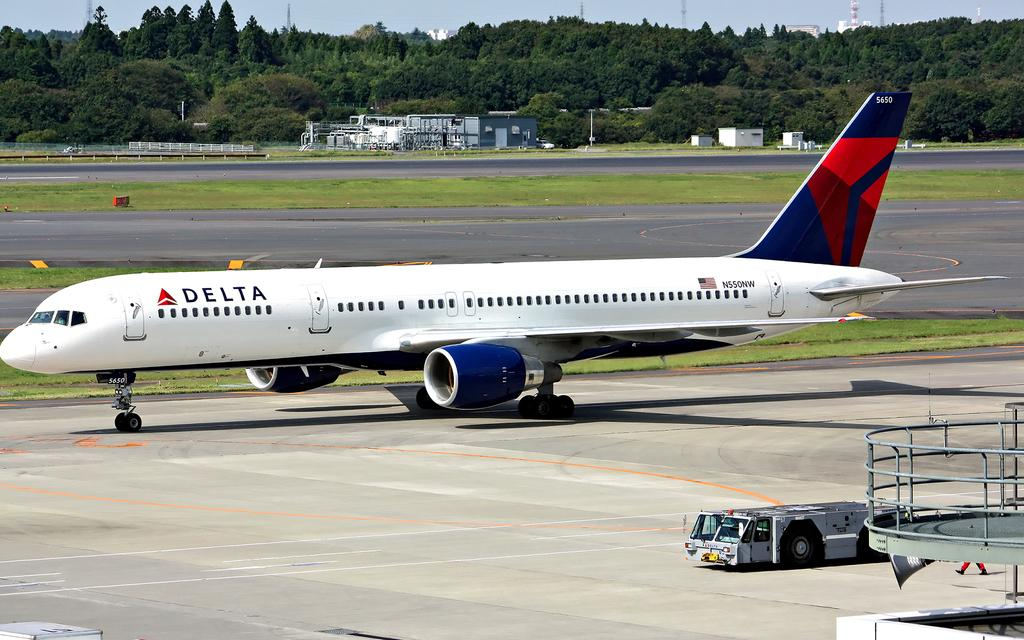<image>
Render a clear and concise summary of the photo. Delta airlines plane N550NW sitting outside on the runway. 